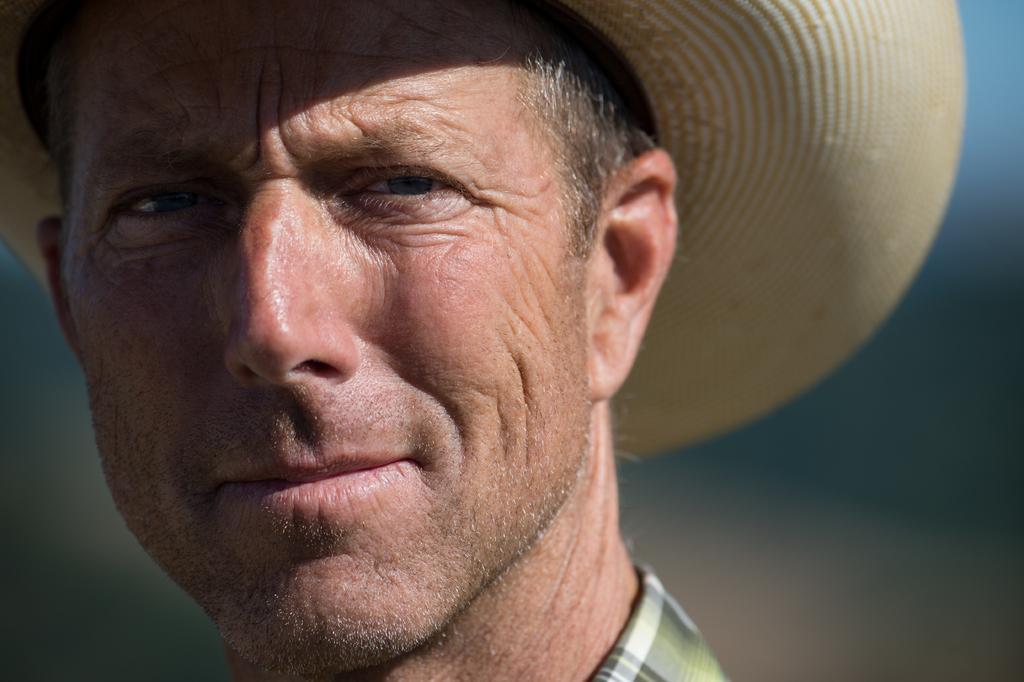In one or two sentences, can you explain what this image depicts? In the picture I can see a man is wearing a hat. The background of the image is blurred. 